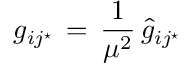Convert formula to latex. <formula><loc_0><loc_0><loc_500><loc_500>g _ { i j ^ { ^ { * } } } \, = \, { \frac { 1 } { \mu ^ { 2 } } } \, { \hat { g } } _ { i j ^ { ^ { * } } }</formula> 